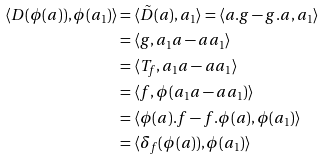Convert formula to latex. <formula><loc_0><loc_0><loc_500><loc_500>\langle D ( \phi ( a ) ) , \phi ( a _ { 1 } ) \rangle & = \langle \tilde { D } ( a ) , a _ { 1 } \rangle = \langle a . g - g . a , a _ { 1 } \rangle \\ & = \langle g , a _ { 1 } a - a a _ { 1 } \rangle \\ & = \langle T _ { f } , a _ { 1 } a - a a _ { 1 } \rangle \\ & = \langle f , \phi ( a _ { 1 } a - a a _ { 1 } ) \rangle \\ & = \langle \phi ( a ) . f - f . \phi ( a ) , \phi ( a _ { 1 } ) \rangle \\ & = \langle \delta _ { f } ( \phi ( a ) ) , \phi ( a _ { 1 } ) \rangle</formula> 